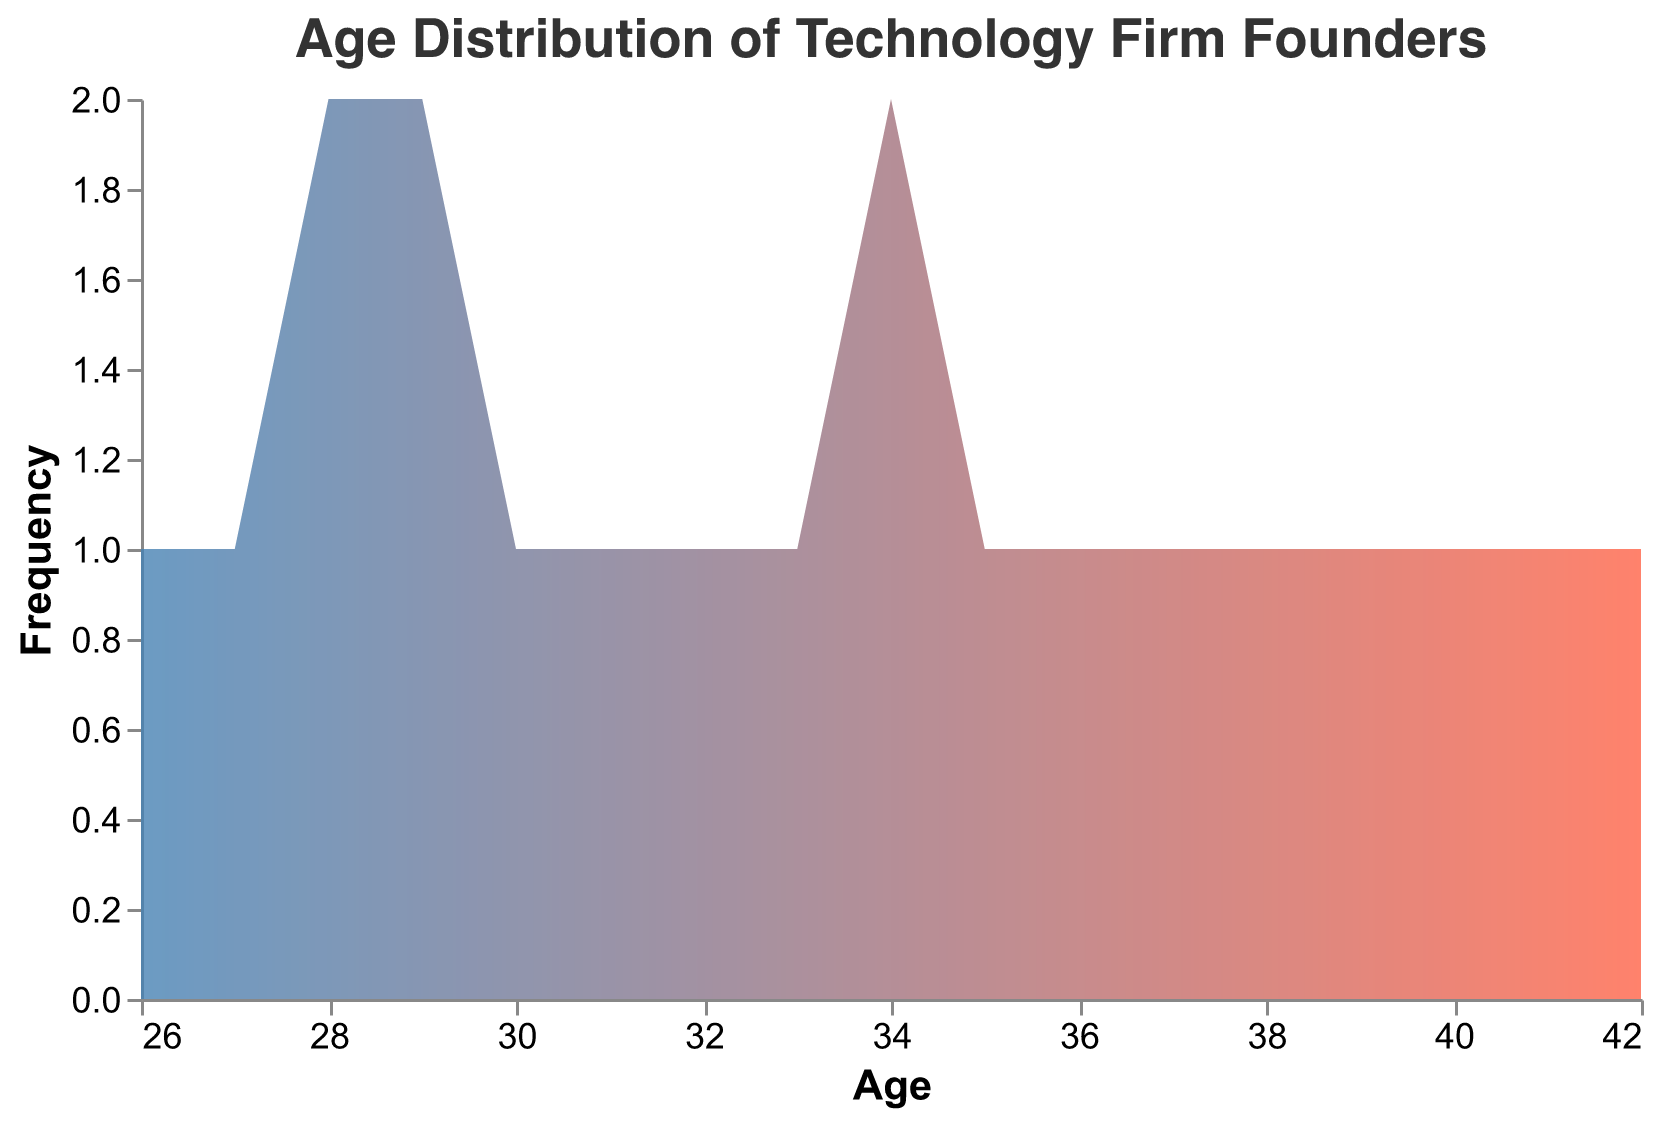What is the title of the plot? The title is the text that appears prominently at the top of the figure. It provides a summary of what the plot represents.
Answer: Age Distribution of Technology Firm Founders What is the range of ages shown on the x-axis? The x-axis represents the age of the founders. The range is determined by looking at the minimum and maximum age values shown along the x-axis.
Answer: 26 to 42 How many founders are within the age range of 28 to 30? To answer this, count the number of data points that fall within the age range of 28 to 30 by looking at the heights of their corresponding bars.
Answer: 5 Which age has the highest frequency of technology firm founders? Identify the tallest bar on the y-axis. The age corresponding to this bar represents the age with the highest frequency of founders.
Answer: 34 What is the median age of the founders? The median age is the middle value when the ages are arranged in ascending order. With 20 data points, the median is the average of the 10th and 11th values in the sorted list. Ages sorted: 26, 27, 28, 28, 29, 29, 29, 30, 31, 32, 33, 34, 34, 35, 36, 37, 38, 39, 40, 41, 42. The 10th and 11th values are 32 and 33, so the median is (32+33)/2 = 32.5.
Answer: 32.5 Is the frequency distribution of ages symmetrical? Check if the frequency distribution around the center (median) is similar on both sides. A symmetrical distribution would have similar frequencies for ages equidistant from the median. If not, note the skewness.
Answer: No What is the difference in frequency between the youngest and oldest age groups of founders? Identify the count of founders in the youngest age group (around age 26) and the oldest age group (around age 42). Subtract the frequency of the youngest from the oldest. Youngest: 1, Oldest: 1. Difference: 1 - 1 = 0.
Answer: 0 How many founding ages have a frequency greater than 2? Count the number of age groups where the corresponding bars have a height greater than 2 on the y-axis.
Answer: 3 Which region has the most founders aged 34? Identify the region(s) with data points of age 34 by looking at the founder details and count the occurrences. The data shows Silicon Valley has 1, Boston has 2.
Answer: Boston Are there more founders in their 30s or 40s? Add up the frequencies for ages 30 to 39 and compare it with the sum of frequencies for ages 40 to 49. Ages in 30s: 30, 31, 32, 33, 34, 35, 36, 37, 38, 39. Ages in 40s: 40, 41, 42. Count each from the plot and compare totals.
Answer: 30s 